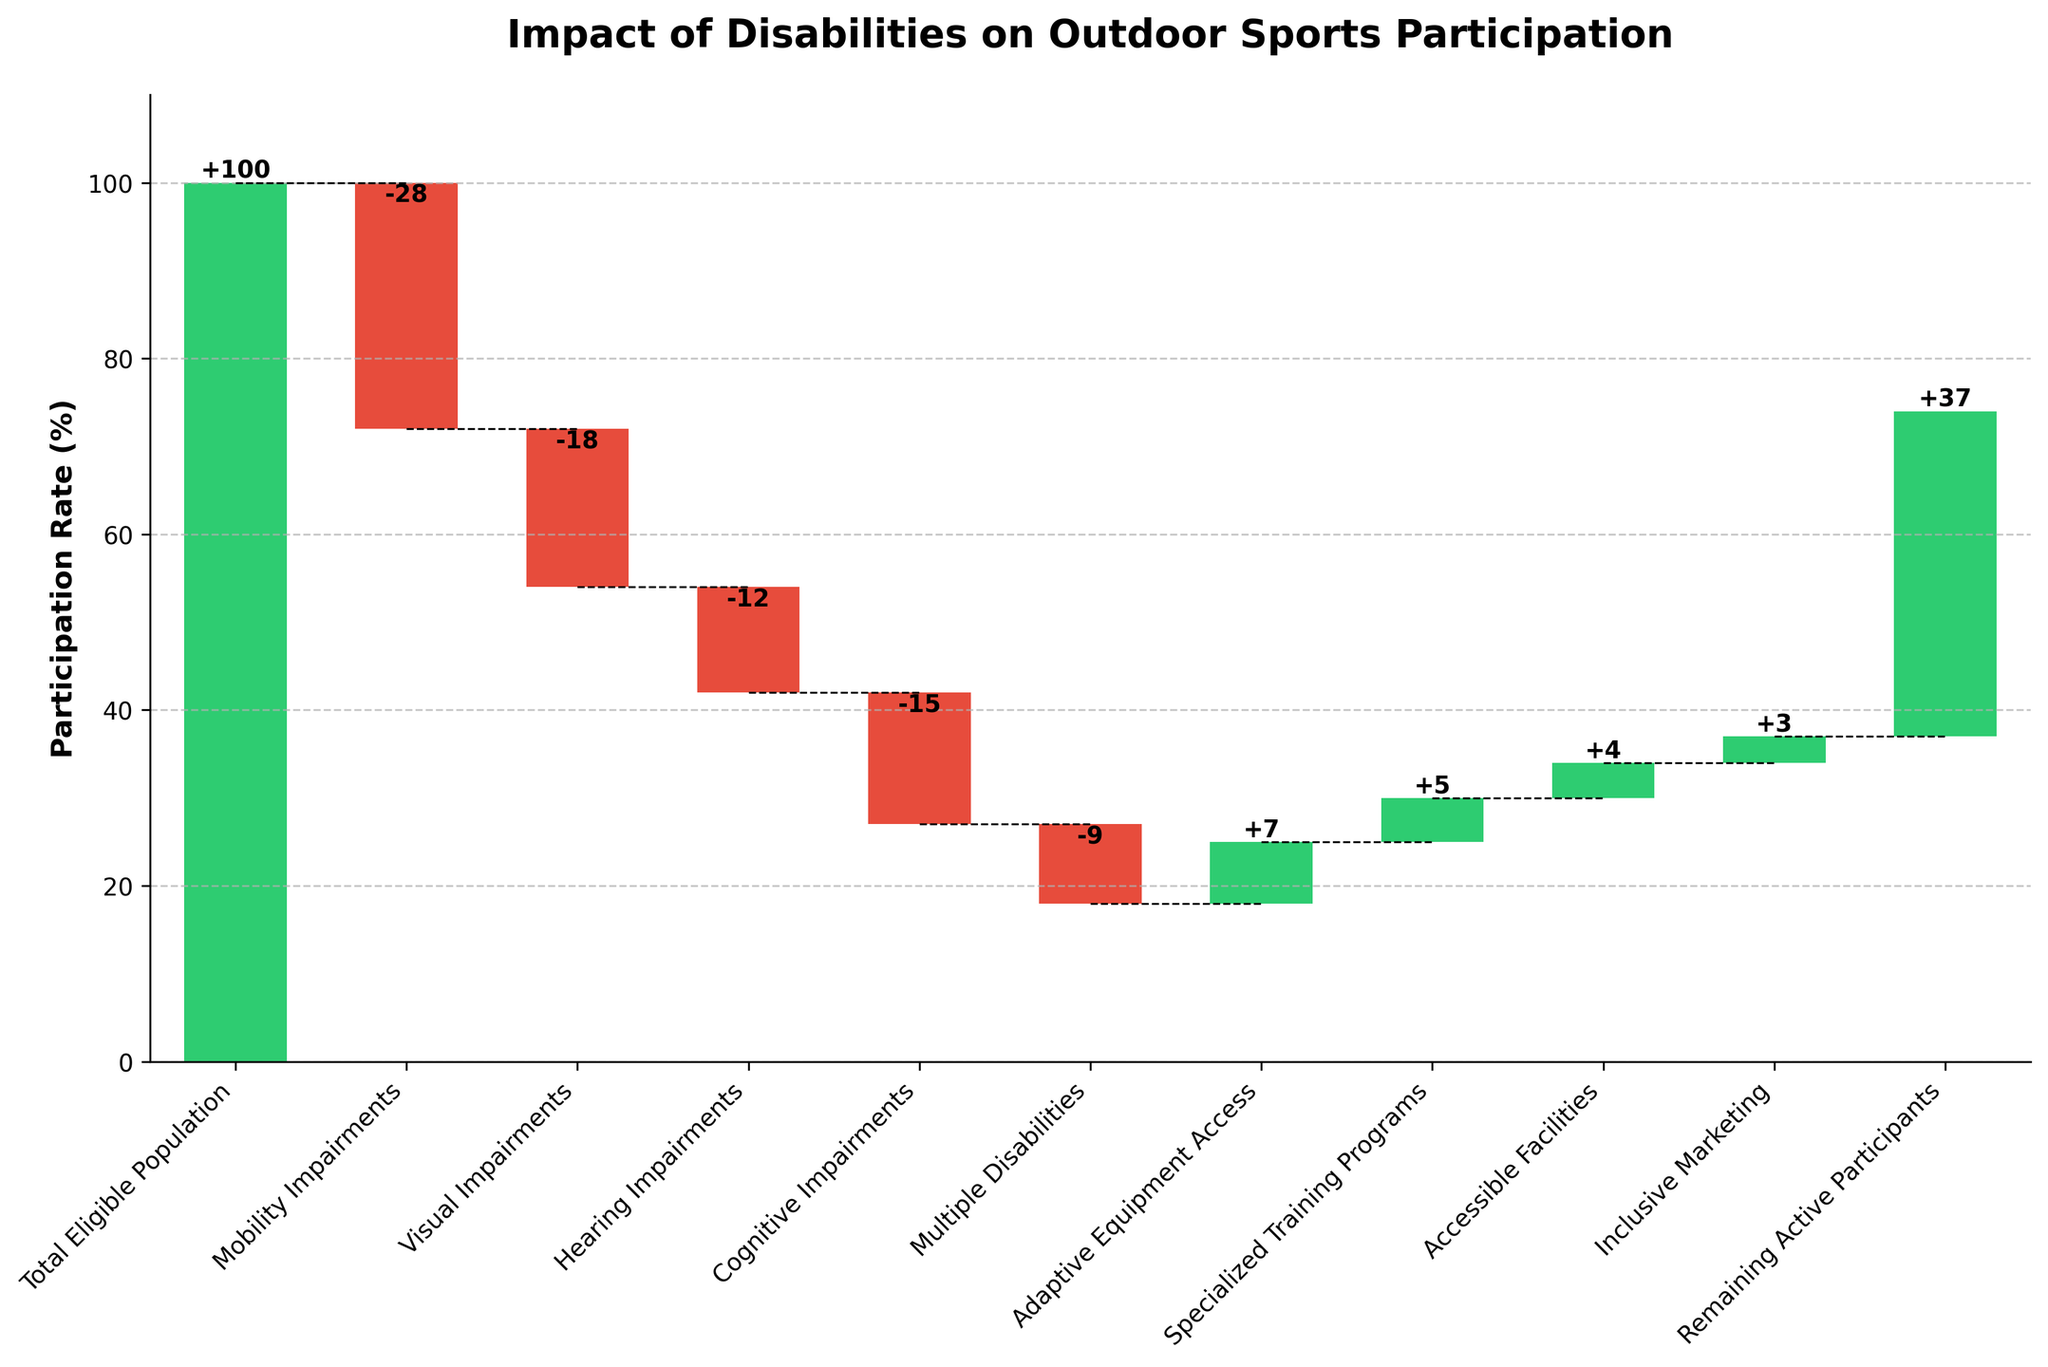How many categories have a negative impact on participation rates? To determine this, count the number of categories with negative values. The categories are Mobility Impairments, Visual Impairments, Hearing Impairments, Cognitive Impairments, and Multiple Disabilities.
Answer: 5 What is the total impact of positive factors on participation rates? Sum the values of the positive categories: Adaptive Equipment Access (+7), Specialized Training Programs (+5), Accessible Facilities (+4), and Inclusive Marketing (+3). 7 + 5 + 4 + 3 = 19.
Answer: 19 What is the overall reduction in participation rates due to disabilities? Add up the negative values representing the reduction due to disabilities: -28 + -18 + -12 + -15 + -9. The total reduction in participation is -82.
Answer: 82 Which category has the most negative impact on participation rates? Identify the category with the largest negative value. Mobility Impairments have the value of -28, which is the most negative impact.
Answer: Mobility Impairments By how much would remaining active participants increase if only positive factors were considered? The total positive impact is +19. Adding this to the remaining active participants (which is 37) would result in 37 + 19 = 56.
Answer: 56 How much do cognitive impairments and hearing impairments together reduce participation rates? Sum the negative impact values of Cognitive Impairments and Hearing Impairments: -15 (Cognitive Impairments) + -12 (Hearing Impairments) = -27.
Answer: 27 Is the increase due to Adaptive Equipment Access greater than the decrease due to Visual Impairments? Compare the positive impact of Adaptive Equipment Access (+7) with the negative impact of Visual Impairments (-18). 7 is less than 18, so the increase is not greater.
Answer: No What is the final percentage of remaining active participants? Starting from 100 (Total Eligible Population), subtract the total negative impacts and add the total positive impacts. The final remaining active participants are 37, as shown in the last category.
Answer: 37% Which factor among the positive ones has the least impact on participation rates? Compare the positive impact values: Adaptive Equipment Access (+7), Specialized Training Programs (+5), Accessible Facilities (+4), and Inclusive Marketing (+3). Inclusive Marketing has the smallest positive impact with +3.
Answer: Inclusive Marketing 